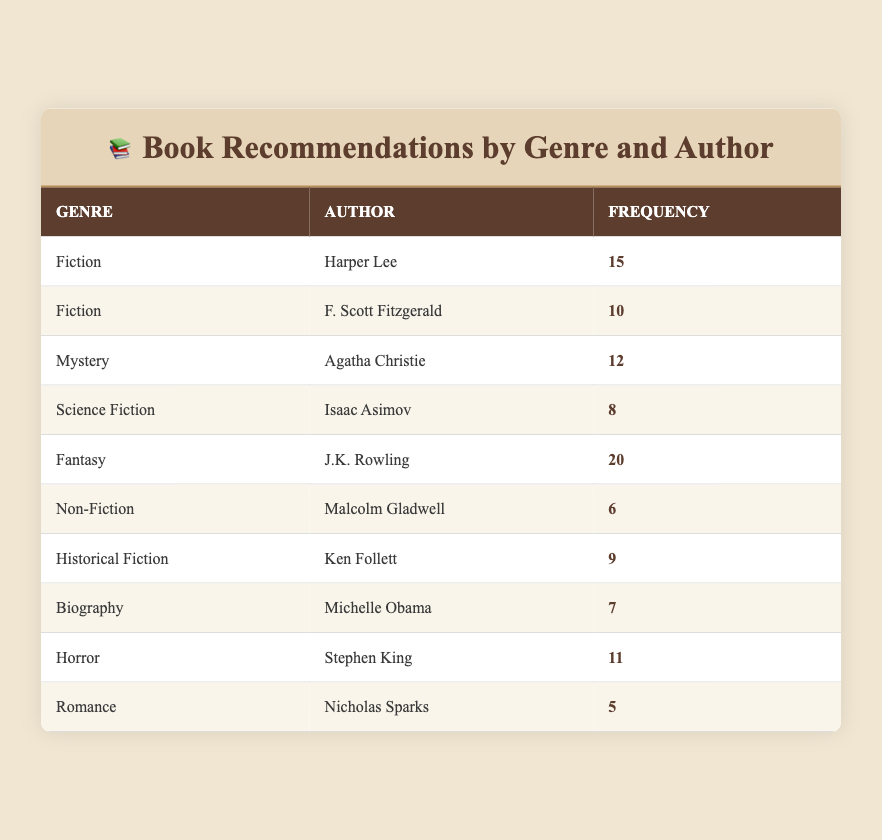What is the genre of the author with the highest recommendation frequency? The author with the highest recommendation frequency is J.K. Rowling with a frequency of 20. Referring to the table, she falls under the genre "Fantasy."
Answer: Fantasy How many recommendations are there for Stephen King? The table shows that the frequency of recommendations for Stephen King is 11.
Answer: 11 Which genre has the least number of recommendations? The genre with the least number of recommendations is "Romance," with a frequency of 5 as noted in the table.
Answer: Romance What is the combined frequency of recommendations for Fiction and Mystery genres? The frequency for Fiction is 15 (Harper Lee) + 10 (F. Scott Fitzgerald) = 25, and for Mystery, it is 12 (Agatha Christie). When we combine these, we get 25 + 12 = 37.
Answer: 37 Is there an author in the Horror genre with a frequency greater than 10? Yes, according to the table, Stephen King in the Horror genre has a frequency of 11, which is greater than 10.
Answer: Yes Which author has more recommendations, Malcolm Gladwell or Michelle Obama? The recommendations for Malcolm Gladwell is 6, while Michelle Obama has 7. Since 7 is greater than 6, Michelle Obama has more recommendations than Malcolm Gladwell.
Answer: Michelle Obama What is the average frequency of recommendations across all genres? To find the average, first sum the frequencies: 15 + 10 + 12 + 8 + 20 + 6 + 9 + 7 + 11 + 5 = 99. Then, divide by the number of authors, which is 10. So, 99 / 10 = 9.9.
Answer: 9.9 How many authors are there from the Fantasy genre? Referring to the table, it is noted that there is only one author from the Fantasy genre, which is J.K. Rowling.
Answer: 1 Which genre has a higher total frequency: Historical Fiction or Non-Fiction? The Historical Fiction genre has 9 (Ken Follett) and Non-Fiction has 6 (Malcolm Gladwell). Comparing these, 9 is greater than 6, indicating Historical Fiction has a higher total frequency.
Answer: Historical Fiction 